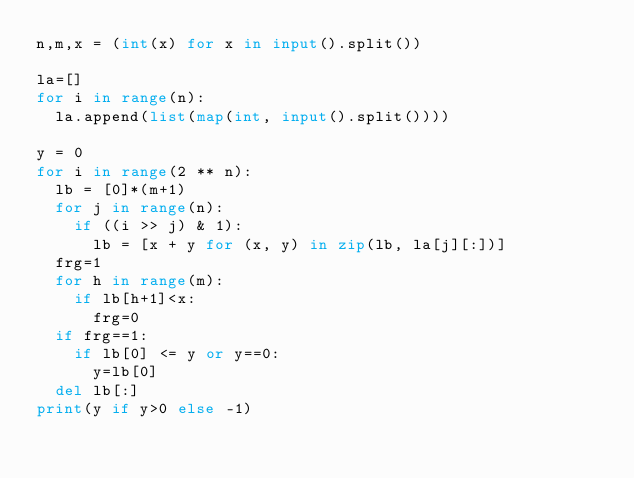<code> <loc_0><loc_0><loc_500><loc_500><_Python_>n,m,x = (int(x) for x in input().split())

la=[]
for i in range(n):
  la.append(list(map(int, input().split())))

y = 0
for i in range(2 ** n):
  lb = [0]*(m+1)
  for j in range(n):
    if ((i >> j) & 1):
      lb = [x + y for (x, y) in zip(lb, la[j][:])] 
  frg=1
  for h in range(m):
    if lb[h+1]<x:
      frg=0
  if frg==1:
    if lb[0] <= y or y==0:
      y=lb[0]
  del lb[:]
print(y if y>0 else -1)</code> 